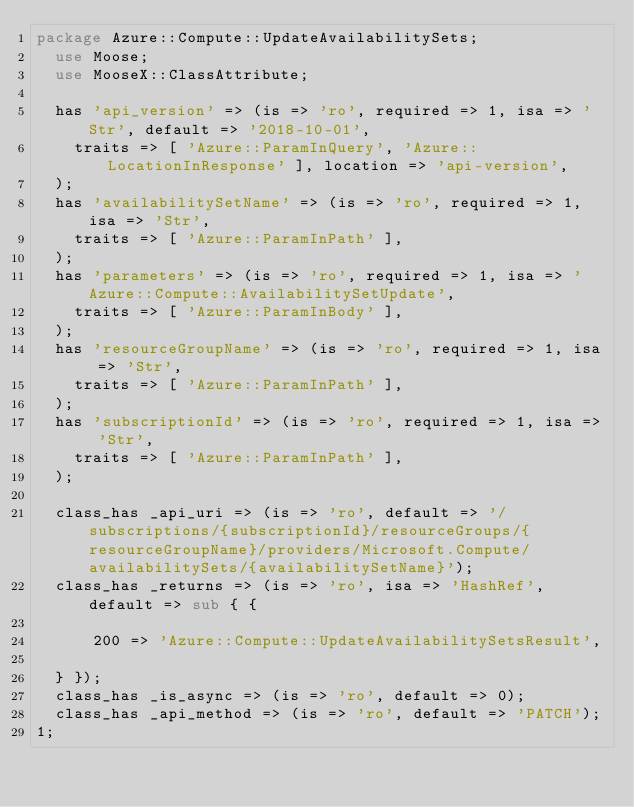Convert code to text. <code><loc_0><loc_0><loc_500><loc_500><_Perl_>package Azure::Compute::UpdateAvailabilitySets;
  use Moose;
  use MooseX::ClassAttribute;

  has 'api_version' => (is => 'ro', required => 1, isa => 'Str', default => '2018-10-01',
    traits => [ 'Azure::ParamInQuery', 'Azure::LocationInResponse' ], location => 'api-version',
  );
  has 'availabilitySetName' => (is => 'ro', required => 1, isa => 'Str',
    traits => [ 'Azure::ParamInPath' ],
  );
  has 'parameters' => (is => 'ro', required => 1, isa => 'Azure::Compute::AvailabilitySetUpdate',
    traits => [ 'Azure::ParamInBody' ],
  );
  has 'resourceGroupName' => (is => 'ro', required => 1, isa => 'Str',
    traits => [ 'Azure::ParamInPath' ],
  );
  has 'subscriptionId' => (is => 'ro', required => 1, isa => 'Str',
    traits => [ 'Azure::ParamInPath' ],
  );

  class_has _api_uri => (is => 'ro', default => '/subscriptions/{subscriptionId}/resourceGroups/{resourceGroupName}/providers/Microsoft.Compute/availabilitySets/{availabilitySetName}');
  class_has _returns => (is => 'ro', isa => 'HashRef', default => sub { {
    
      200 => 'Azure::Compute::UpdateAvailabilitySetsResult',
    
  } });
  class_has _is_async => (is => 'ro', default => 0);
  class_has _api_method => (is => 'ro', default => 'PATCH');
1;
</code> 